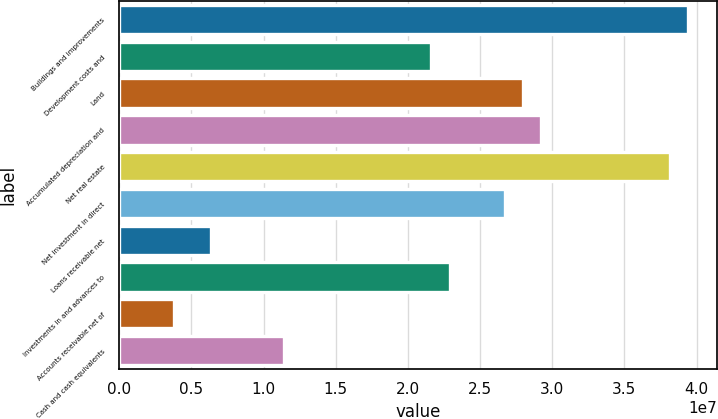<chart> <loc_0><loc_0><loc_500><loc_500><bar_chart><fcel>Buildings and improvements<fcel>Development costs and<fcel>Land<fcel>Accumulated depreciation and<fcel>Net real estate<fcel>Net investment in direct<fcel>Loans receivable net<fcel>Investments in and advances to<fcel>Accounts receivable net of<fcel>Cash and cash equivalents<nl><fcel>3.94252e+07<fcel>2.16208e+07<fcel>2.79795e+07<fcel>2.92512e+07<fcel>3.81534e+07<fcel>2.67077e+07<fcel>6.35984e+06<fcel>2.28925e+07<fcel>3.81635e+06<fcel>1.14468e+07<nl></chart> 